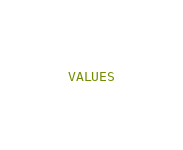Convert code to text. <code><loc_0><loc_0><loc_500><loc_500><_SQL_>VALUES</code> 